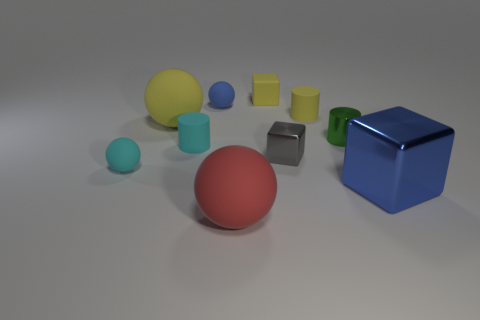Subtract all red matte balls. How many balls are left? 3 Subtract 1 balls. How many balls are left? 3 Subtract all red spheres. How many spheres are left? 3 Subtract all cylinders. How many objects are left? 7 Subtract all cyan cylinders. Subtract all gray spheres. How many cylinders are left? 2 Subtract all cyan rubber objects. Subtract all tiny gray cubes. How many objects are left? 7 Add 1 tiny blocks. How many tiny blocks are left? 3 Add 4 gray cubes. How many gray cubes exist? 5 Subtract 0 brown cylinders. How many objects are left? 10 